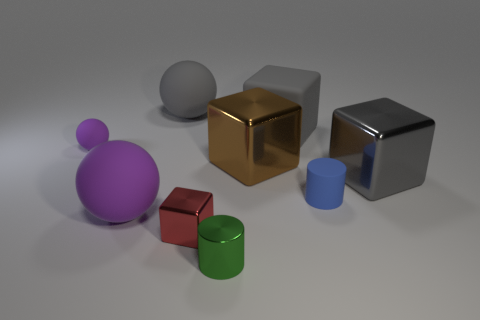What is the size of the gray cube in front of the large matte object on the right side of the large gray object behind the gray rubber cube?
Your answer should be very brief. Large. Is the small red block made of the same material as the large gray thing to the right of the small blue matte cylinder?
Keep it short and to the point. Yes. Do the green object and the brown shiny object have the same shape?
Provide a succinct answer. No. How many other objects are the same material as the small blue thing?
Provide a succinct answer. 4. How many other tiny metallic things have the same shape as the tiny purple thing?
Offer a very short reply. 0. What color is the block that is to the left of the tiny blue cylinder and right of the brown cube?
Your response must be concise. Gray. How many small gray metal balls are there?
Offer a terse response. 0. Is the size of the red block the same as the blue matte object?
Offer a terse response. Yes. Is there a big matte block of the same color as the tiny block?
Make the answer very short. No. There is a large thing that is to the right of the tiny blue cylinder; does it have the same shape as the blue object?
Your answer should be compact. No. 